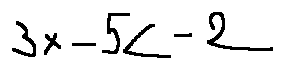Convert formula to latex. <formula><loc_0><loc_0><loc_500><loc_500>3 x - 5 < - 2</formula> 